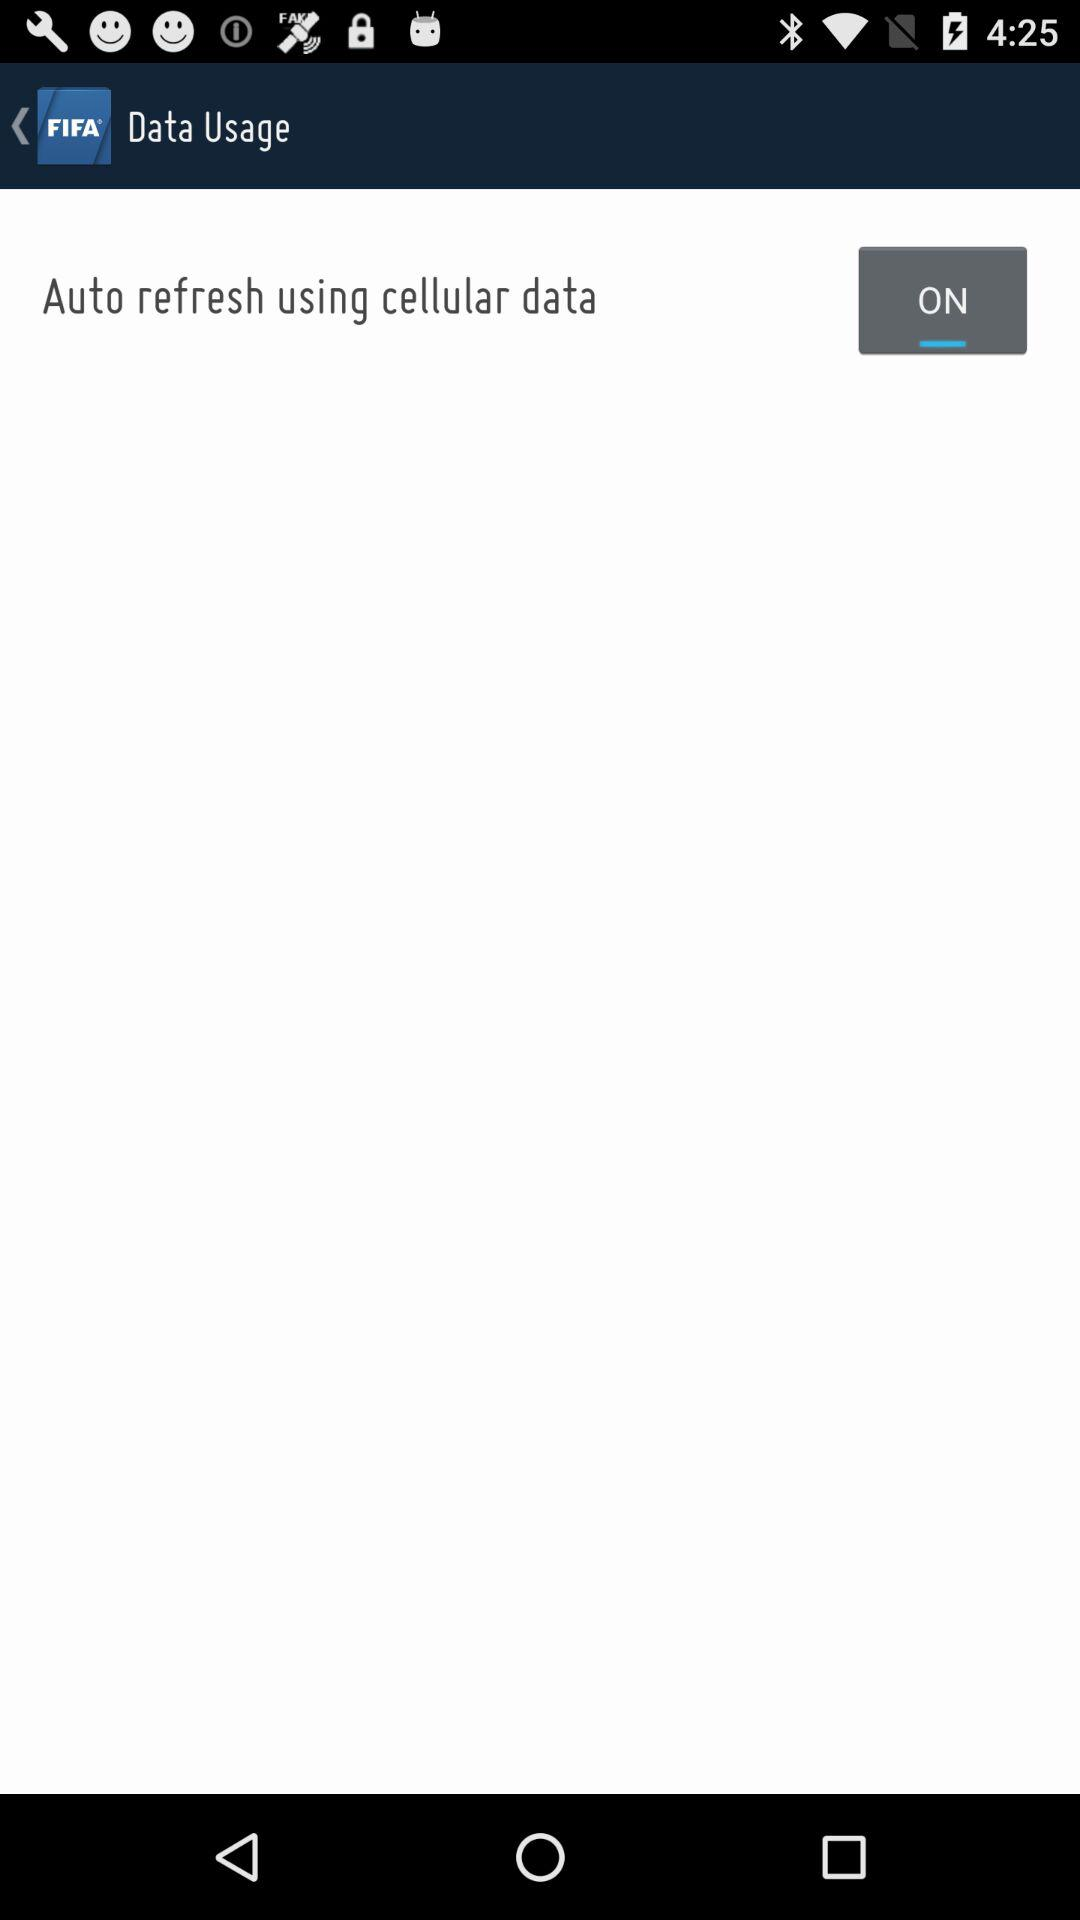What is the status of "Auto refresh using cellular data"? The status is "on". 